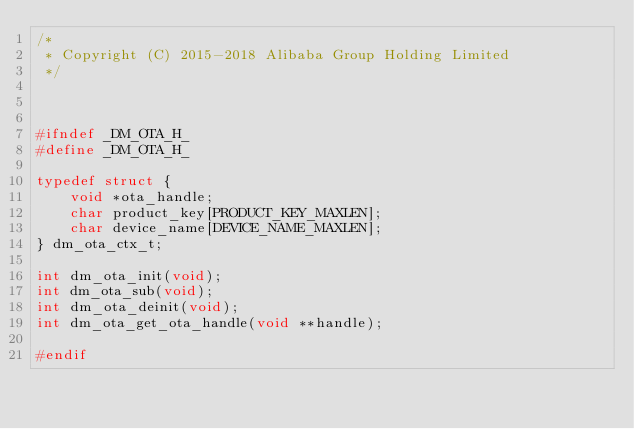<code> <loc_0><loc_0><loc_500><loc_500><_C_>/*
 * Copyright (C) 2015-2018 Alibaba Group Holding Limited
 */



#ifndef _DM_OTA_H_
#define _DM_OTA_H_

typedef struct {
    void *ota_handle;
    char product_key[PRODUCT_KEY_MAXLEN];
    char device_name[DEVICE_NAME_MAXLEN];
} dm_ota_ctx_t;

int dm_ota_init(void);
int dm_ota_sub(void);
int dm_ota_deinit(void);
int dm_ota_get_ota_handle(void **handle);

#endif</code> 